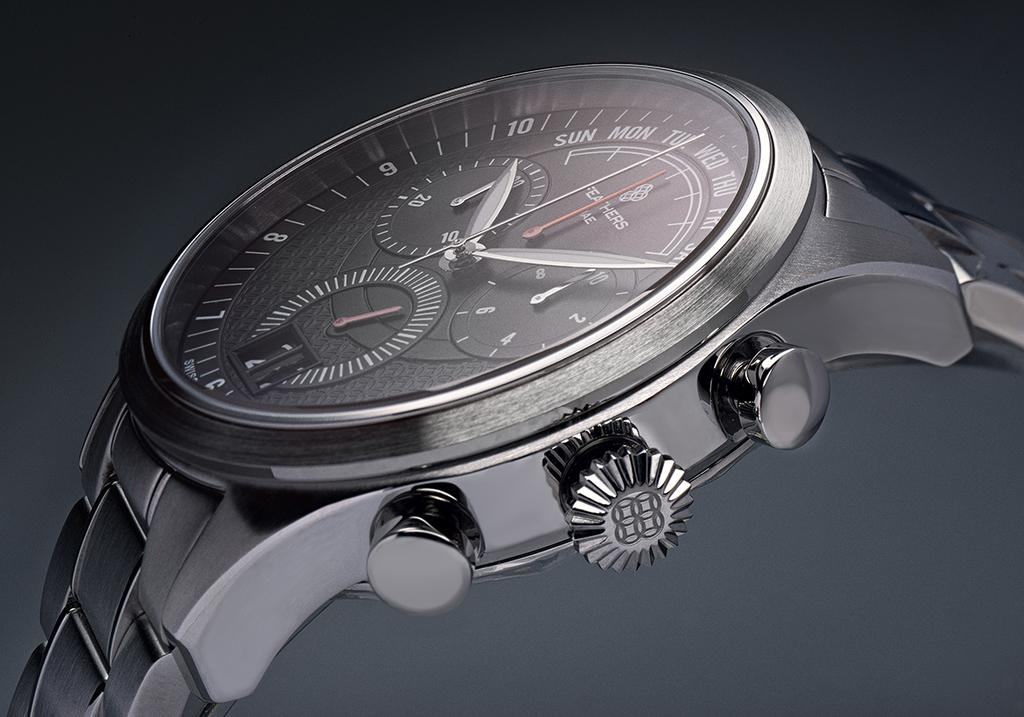<image>
Provide a brief description of the given image. Face of a watch which says "Feathers" on it. 